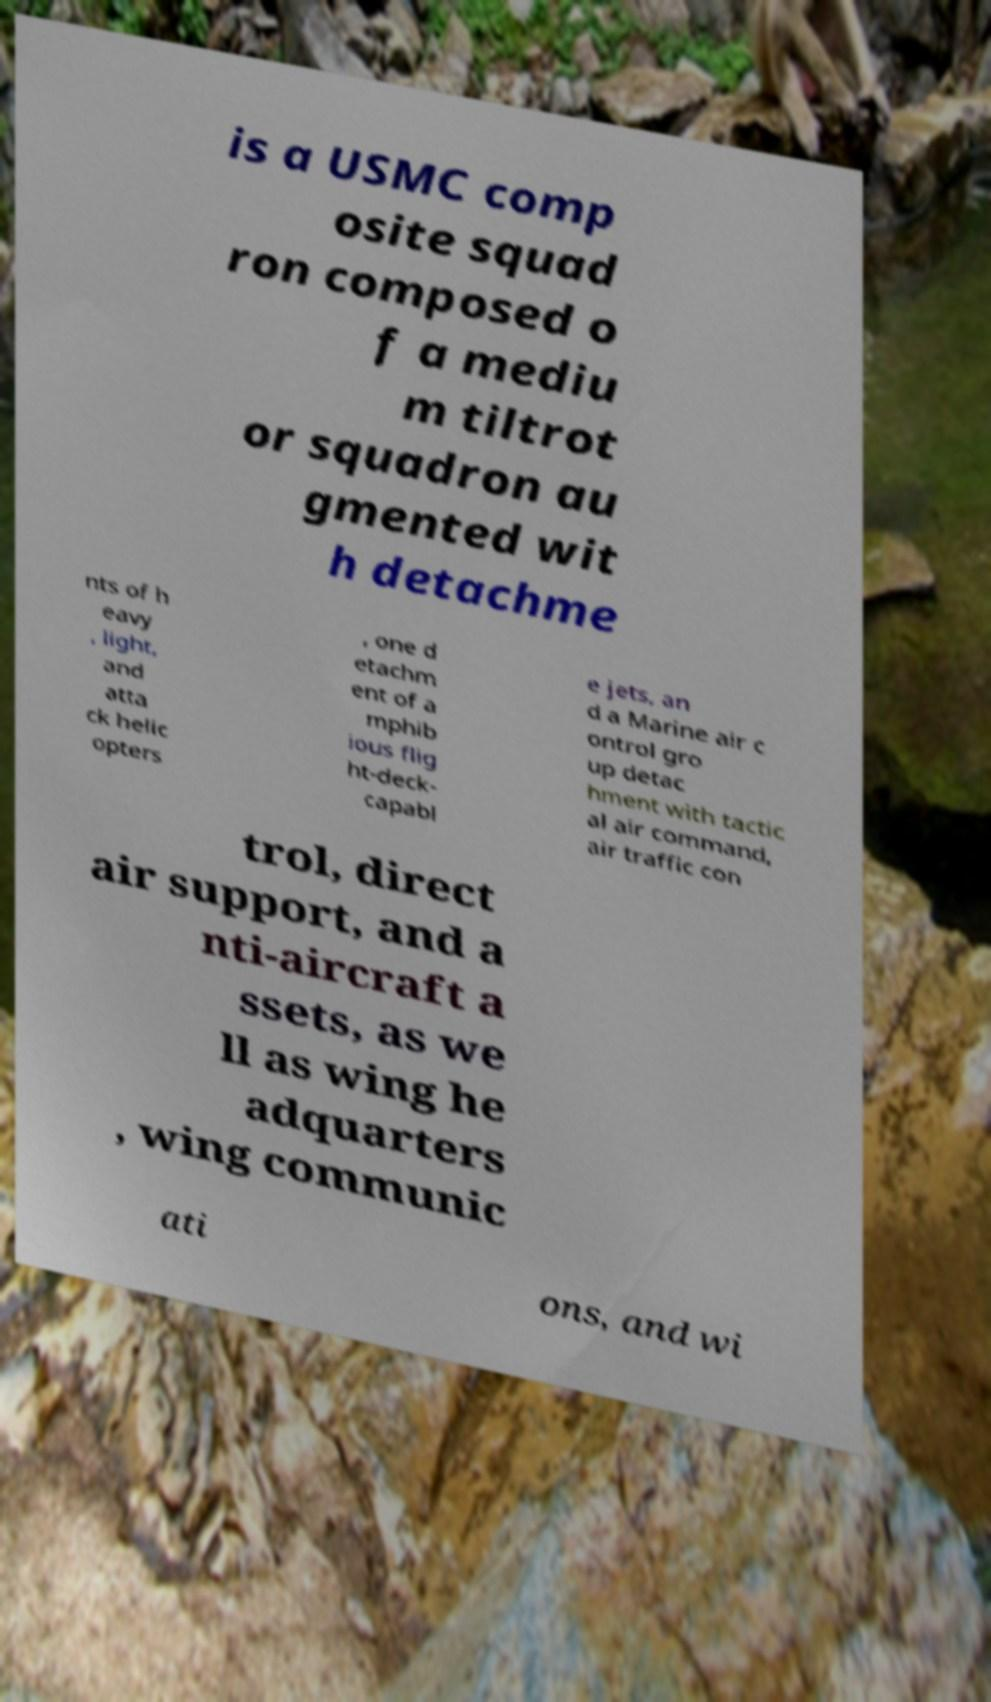There's text embedded in this image that I need extracted. Can you transcribe it verbatim? is a USMC comp osite squad ron composed o f a mediu m tiltrot or squadron au gmented wit h detachme nts of h eavy , light, and atta ck helic opters , one d etachm ent of a mphib ious flig ht-deck- capabl e jets, an d a Marine air c ontrol gro up detac hment with tactic al air command, air traffic con trol, direct air support, and a nti-aircraft a ssets, as we ll as wing he adquarters , wing communic ati ons, and wi 